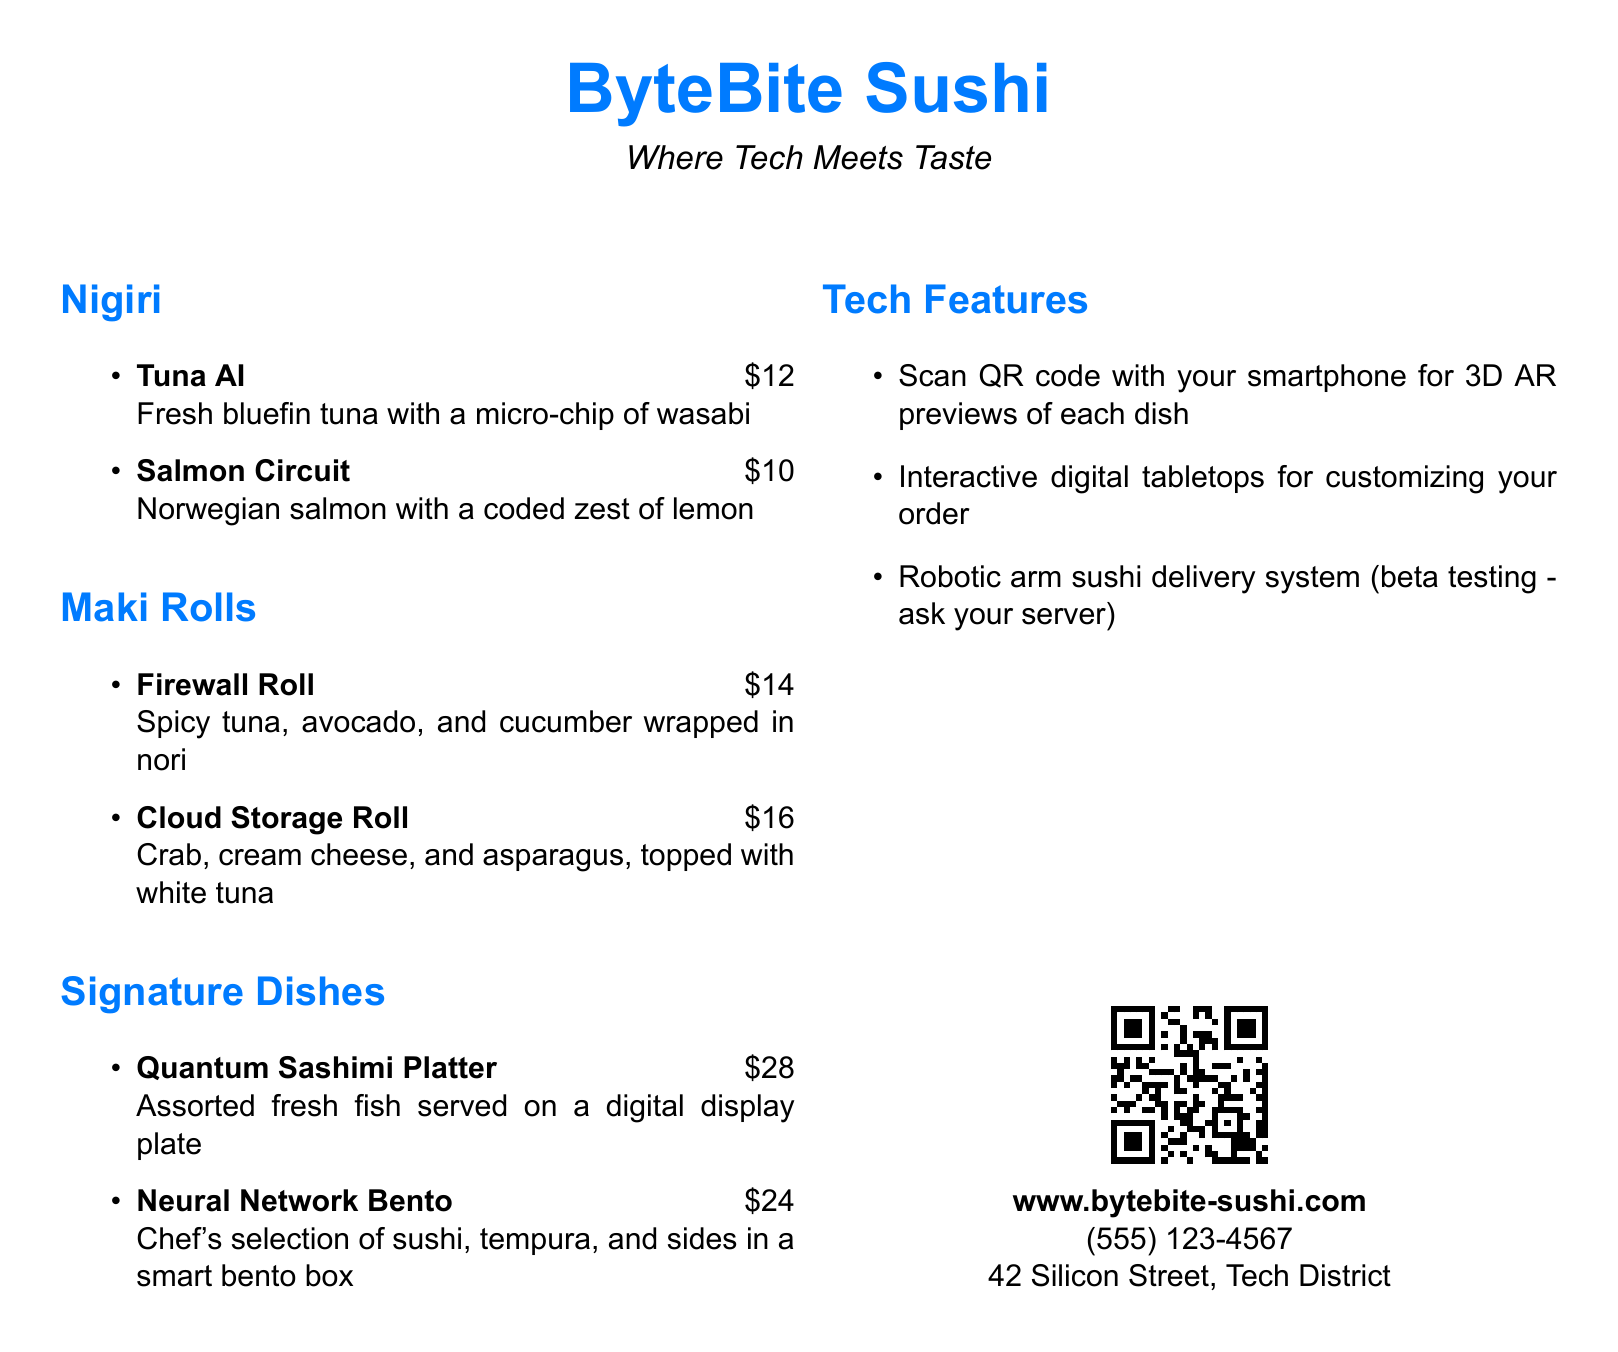What is the name of the restaurant? The restaurant's name is clearly stated at the top of the menu.
Answer: ByteBite Sushi How much does the Firewall Roll cost? The cost of the Firewall Roll is listed under the Maki Rolls section of the menu.
Answer: $14 What type of fish is used in the Tuna AI dish? The dish description specifies that it uses fresh bluefin tuna.
Answer: Bluefin tuna What tech feature allows you to preview dishes? The menu describes a tech feature that utilizes a QR code for previews.
Answer: QR code What is included in the Neural Network Bento? The menu mentions that it includes chef's selection of sushi, tempura, and sides.
Answer: Sushi, tempura, and sides How much is the Quantum Sashimi Platter? The price for the Quantum Sashimi Platter is stated in the Signature Dishes section.
Answer: $28 Which dish has crab and cream cheese? The menu lists the Cloud Storage Roll as the dish containing crab and cream cheese.
Answer: Cloud Storage Roll What is the phone number for the restaurant? The phone number is provided in the contact section at the bottom of the menu.
Answer: (555) 123-4567 What feature is currently in beta testing? The menu specifies that there is a robotic arm sushi delivery system in beta testing.
Answer: Robotic arm sushi delivery system 